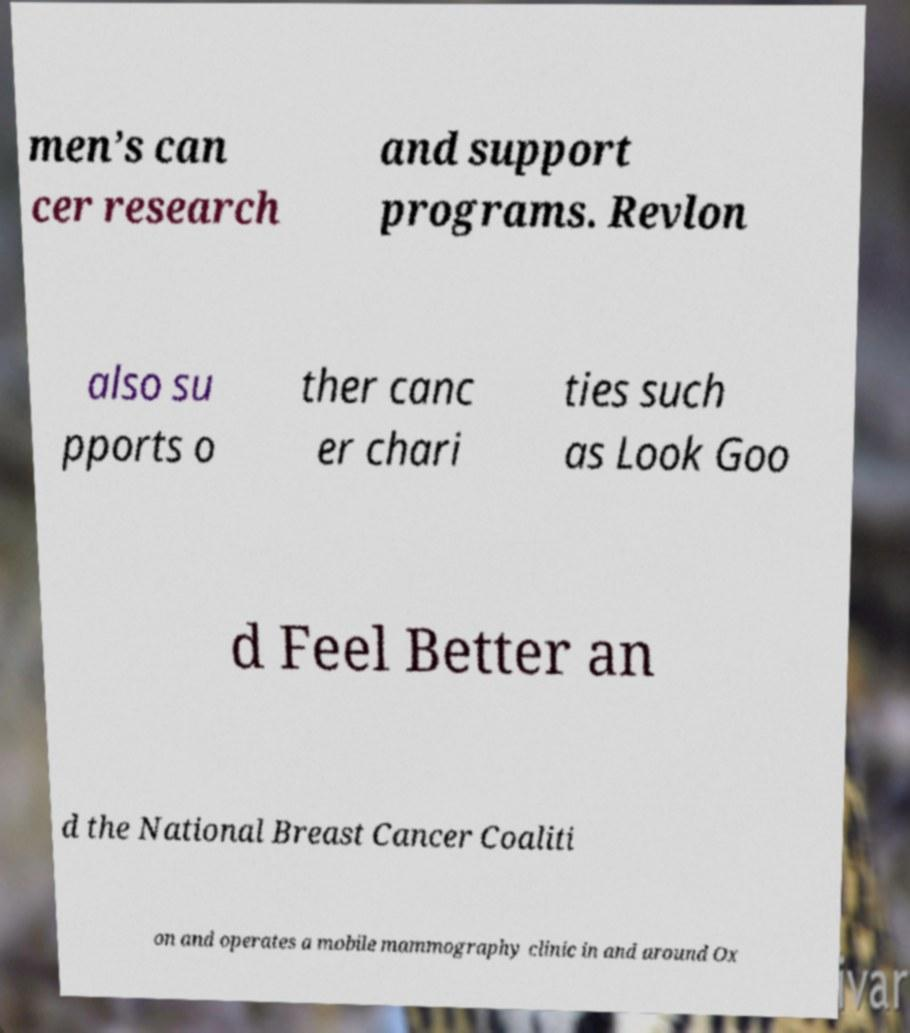Could you assist in decoding the text presented in this image and type it out clearly? men’s can cer research and support programs. Revlon also su pports o ther canc er chari ties such as Look Goo d Feel Better an d the National Breast Cancer Coaliti on and operates a mobile mammography clinic in and around Ox 